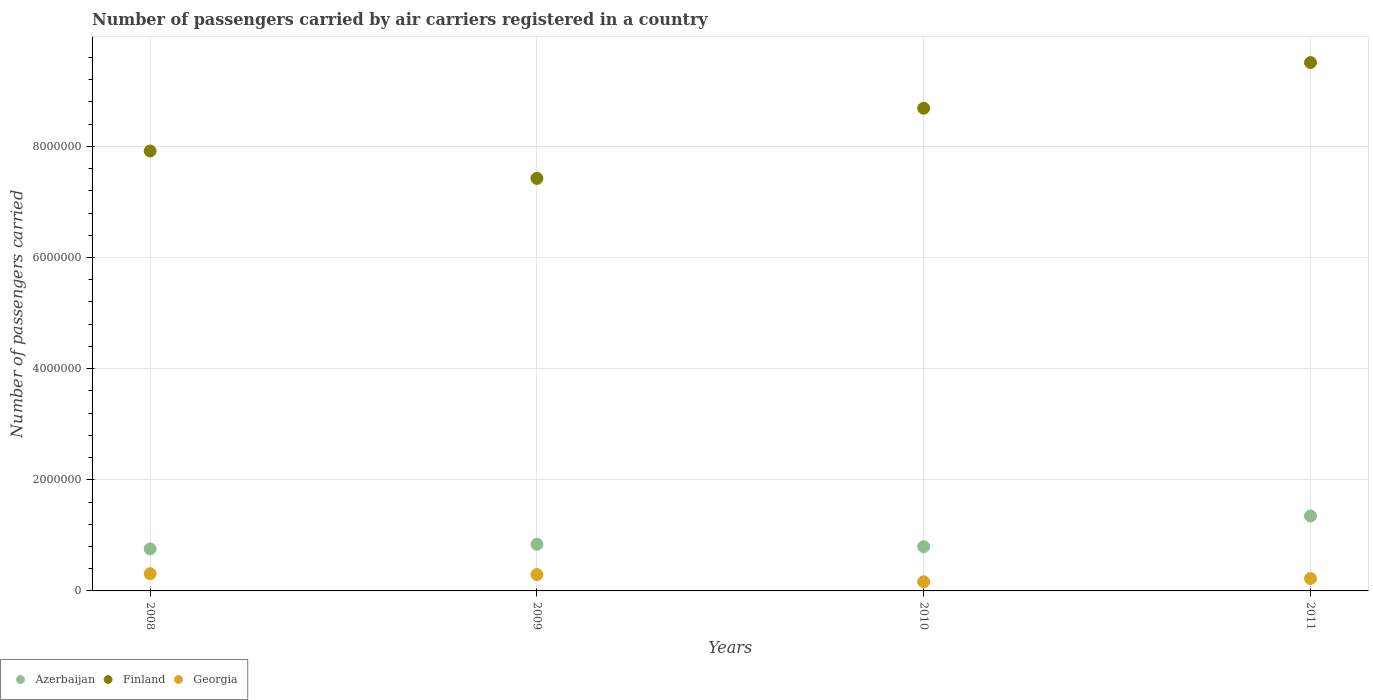How many different coloured dotlines are there?
Your answer should be very brief. 3. Is the number of dotlines equal to the number of legend labels?
Provide a short and direct response. Yes. What is the number of passengers carried by air carriers in Georgia in 2011?
Provide a short and direct response. 2.23e+05. Across all years, what is the maximum number of passengers carried by air carriers in Georgia?
Provide a short and direct response. 3.10e+05. Across all years, what is the minimum number of passengers carried by air carriers in Azerbaijan?
Provide a succinct answer. 7.56e+05. What is the total number of passengers carried by air carriers in Finland in the graph?
Your answer should be very brief. 3.35e+07. What is the difference between the number of passengers carried by air carriers in Georgia in 2008 and that in 2010?
Ensure brevity in your answer.  1.46e+05. What is the difference between the number of passengers carried by air carriers in Finland in 2008 and the number of passengers carried by air carriers in Georgia in 2009?
Provide a short and direct response. 7.62e+06. What is the average number of passengers carried by air carriers in Georgia per year?
Offer a terse response. 2.48e+05. In the year 2009, what is the difference between the number of passengers carried by air carriers in Georgia and number of passengers carried by air carriers in Azerbaijan?
Offer a terse response. -5.45e+05. In how many years, is the number of passengers carried by air carriers in Georgia greater than 8400000?
Offer a very short reply. 0. What is the ratio of the number of passengers carried by air carriers in Georgia in 2010 to that in 2011?
Provide a short and direct response. 0.74. What is the difference between the highest and the second highest number of passengers carried by air carriers in Georgia?
Provide a short and direct response. 1.58e+04. What is the difference between the highest and the lowest number of passengers carried by air carriers in Georgia?
Give a very brief answer. 1.46e+05. In how many years, is the number of passengers carried by air carriers in Finland greater than the average number of passengers carried by air carriers in Finland taken over all years?
Offer a very short reply. 2. Is the sum of the number of passengers carried by air carriers in Azerbaijan in 2010 and 2011 greater than the maximum number of passengers carried by air carriers in Georgia across all years?
Ensure brevity in your answer.  Yes. Does the number of passengers carried by air carriers in Azerbaijan monotonically increase over the years?
Provide a succinct answer. No. Is the number of passengers carried by air carriers in Georgia strictly less than the number of passengers carried by air carriers in Finland over the years?
Offer a terse response. Yes. Does the graph contain any zero values?
Provide a succinct answer. No. Does the graph contain grids?
Ensure brevity in your answer.  Yes. How many legend labels are there?
Make the answer very short. 3. How are the legend labels stacked?
Make the answer very short. Horizontal. What is the title of the graph?
Offer a terse response. Number of passengers carried by air carriers registered in a country. Does "East Asia (developing only)" appear as one of the legend labels in the graph?
Make the answer very short. No. What is the label or title of the X-axis?
Offer a very short reply. Years. What is the label or title of the Y-axis?
Give a very brief answer. Number of passengers carried. What is the Number of passengers carried of Azerbaijan in 2008?
Give a very brief answer. 7.56e+05. What is the Number of passengers carried in Finland in 2008?
Ensure brevity in your answer.  7.92e+06. What is the Number of passengers carried of Georgia in 2008?
Your response must be concise. 3.10e+05. What is the Number of passengers carried of Azerbaijan in 2009?
Your answer should be very brief. 8.40e+05. What is the Number of passengers carried in Finland in 2009?
Your response must be concise. 7.42e+06. What is the Number of passengers carried in Georgia in 2009?
Your response must be concise. 2.94e+05. What is the Number of passengers carried of Azerbaijan in 2010?
Ensure brevity in your answer.  7.97e+05. What is the Number of passengers carried in Finland in 2010?
Your answer should be compact. 8.69e+06. What is the Number of passengers carried of Georgia in 2010?
Provide a short and direct response. 1.64e+05. What is the Number of passengers carried of Azerbaijan in 2011?
Your answer should be very brief. 1.35e+06. What is the Number of passengers carried in Finland in 2011?
Your answer should be very brief. 9.51e+06. What is the Number of passengers carried of Georgia in 2011?
Give a very brief answer. 2.23e+05. Across all years, what is the maximum Number of passengers carried in Azerbaijan?
Make the answer very short. 1.35e+06. Across all years, what is the maximum Number of passengers carried in Finland?
Offer a very short reply. 9.51e+06. Across all years, what is the maximum Number of passengers carried of Georgia?
Provide a succinct answer. 3.10e+05. Across all years, what is the minimum Number of passengers carried in Azerbaijan?
Make the answer very short. 7.56e+05. Across all years, what is the minimum Number of passengers carried of Finland?
Provide a succinct answer. 7.42e+06. Across all years, what is the minimum Number of passengers carried of Georgia?
Provide a succinct answer. 1.64e+05. What is the total Number of passengers carried of Azerbaijan in the graph?
Your answer should be compact. 3.74e+06. What is the total Number of passengers carried in Finland in the graph?
Keep it short and to the point. 3.35e+07. What is the total Number of passengers carried in Georgia in the graph?
Give a very brief answer. 9.92e+05. What is the difference between the Number of passengers carried of Azerbaijan in 2008 and that in 2009?
Provide a short and direct response. -8.32e+04. What is the difference between the Number of passengers carried in Finland in 2008 and that in 2009?
Ensure brevity in your answer.  4.93e+05. What is the difference between the Number of passengers carried of Georgia in 2008 and that in 2009?
Offer a very short reply. 1.58e+04. What is the difference between the Number of passengers carried of Azerbaijan in 2008 and that in 2010?
Offer a very short reply. -4.04e+04. What is the difference between the Number of passengers carried of Finland in 2008 and that in 2010?
Your answer should be very brief. -7.69e+05. What is the difference between the Number of passengers carried in Georgia in 2008 and that in 2010?
Ensure brevity in your answer.  1.46e+05. What is the difference between the Number of passengers carried in Azerbaijan in 2008 and that in 2011?
Offer a very short reply. -5.92e+05. What is the difference between the Number of passengers carried in Finland in 2008 and that in 2011?
Keep it short and to the point. -1.59e+06. What is the difference between the Number of passengers carried in Georgia in 2008 and that in 2011?
Offer a very short reply. 8.76e+04. What is the difference between the Number of passengers carried of Azerbaijan in 2009 and that in 2010?
Give a very brief answer. 4.28e+04. What is the difference between the Number of passengers carried in Finland in 2009 and that in 2010?
Offer a terse response. -1.26e+06. What is the difference between the Number of passengers carried in Georgia in 2009 and that in 2010?
Your answer should be very brief. 1.30e+05. What is the difference between the Number of passengers carried in Azerbaijan in 2009 and that in 2011?
Make the answer very short. -5.09e+05. What is the difference between the Number of passengers carried in Finland in 2009 and that in 2011?
Give a very brief answer. -2.08e+06. What is the difference between the Number of passengers carried of Georgia in 2009 and that in 2011?
Make the answer very short. 7.18e+04. What is the difference between the Number of passengers carried of Azerbaijan in 2010 and that in 2011?
Your answer should be very brief. -5.52e+05. What is the difference between the Number of passengers carried in Finland in 2010 and that in 2011?
Provide a short and direct response. -8.22e+05. What is the difference between the Number of passengers carried of Georgia in 2010 and that in 2011?
Give a very brief answer. -5.82e+04. What is the difference between the Number of passengers carried of Azerbaijan in 2008 and the Number of passengers carried of Finland in 2009?
Your answer should be compact. -6.67e+06. What is the difference between the Number of passengers carried in Azerbaijan in 2008 and the Number of passengers carried in Georgia in 2009?
Keep it short and to the point. 4.62e+05. What is the difference between the Number of passengers carried of Finland in 2008 and the Number of passengers carried of Georgia in 2009?
Provide a succinct answer. 7.62e+06. What is the difference between the Number of passengers carried in Azerbaijan in 2008 and the Number of passengers carried in Finland in 2010?
Your answer should be compact. -7.93e+06. What is the difference between the Number of passengers carried in Azerbaijan in 2008 and the Number of passengers carried in Georgia in 2010?
Ensure brevity in your answer.  5.92e+05. What is the difference between the Number of passengers carried in Finland in 2008 and the Number of passengers carried in Georgia in 2010?
Keep it short and to the point. 7.75e+06. What is the difference between the Number of passengers carried in Azerbaijan in 2008 and the Number of passengers carried in Finland in 2011?
Give a very brief answer. -8.75e+06. What is the difference between the Number of passengers carried of Azerbaijan in 2008 and the Number of passengers carried of Georgia in 2011?
Your answer should be compact. 5.34e+05. What is the difference between the Number of passengers carried of Finland in 2008 and the Number of passengers carried of Georgia in 2011?
Your response must be concise. 7.69e+06. What is the difference between the Number of passengers carried in Azerbaijan in 2009 and the Number of passengers carried in Finland in 2010?
Your response must be concise. -7.85e+06. What is the difference between the Number of passengers carried in Azerbaijan in 2009 and the Number of passengers carried in Georgia in 2010?
Keep it short and to the point. 6.75e+05. What is the difference between the Number of passengers carried in Finland in 2009 and the Number of passengers carried in Georgia in 2010?
Make the answer very short. 7.26e+06. What is the difference between the Number of passengers carried in Azerbaijan in 2009 and the Number of passengers carried in Finland in 2011?
Offer a terse response. -8.67e+06. What is the difference between the Number of passengers carried in Azerbaijan in 2009 and the Number of passengers carried in Georgia in 2011?
Make the answer very short. 6.17e+05. What is the difference between the Number of passengers carried in Finland in 2009 and the Number of passengers carried in Georgia in 2011?
Offer a very short reply. 7.20e+06. What is the difference between the Number of passengers carried in Azerbaijan in 2010 and the Number of passengers carried in Finland in 2011?
Provide a succinct answer. -8.71e+06. What is the difference between the Number of passengers carried in Azerbaijan in 2010 and the Number of passengers carried in Georgia in 2011?
Your response must be concise. 5.74e+05. What is the difference between the Number of passengers carried in Finland in 2010 and the Number of passengers carried in Georgia in 2011?
Offer a terse response. 8.46e+06. What is the average Number of passengers carried of Azerbaijan per year?
Ensure brevity in your answer.  9.35e+05. What is the average Number of passengers carried in Finland per year?
Keep it short and to the point. 8.38e+06. What is the average Number of passengers carried in Georgia per year?
Provide a short and direct response. 2.48e+05. In the year 2008, what is the difference between the Number of passengers carried in Azerbaijan and Number of passengers carried in Finland?
Your response must be concise. -7.16e+06. In the year 2008, what is the difference between the Number of passengers carried of Azerbaijan and Number of passengers carried of Georgia?
Make the answer very short. 4.46e+05. In the year 2008, what is the difference between the Number of passengers carried in Finland and Number of passengers carried in Georgia?
Give a very brief answer. 7.61e+06. In the year 2009, what is the difference between the Number of passengers carried in Azerbaijan and Number of passengers carried in Finland?
Keep it short and to the point. -6.58e+06. In the year 2009, what is the difference between the Number of passengers carried of Azerbaijan and Number of passengers carried of Georgia?
Offer a very short reply. 5.45e+05. In the year 2009, what is the difference between the Number of passengers carried in Finland and Number of passengers carried in Georgia?
Ensure brevity in your answer.  7.13e+06. In the year 2010, what is the difference between the Number of passengers carried in Azerbaijan and Number of passengers carried in Finland?
Make the answer very short. -7.89e+06. In the year 2010, what is the difference between the Number of passengers carried in Azerbaijan and Number of passengers carried in Georgia?
Offer a very short reply. 6.32e+05. In the year 2010, what is the difference between the Number of passengers carried of Finland and Number of passengers carried of Georgia?
Provide a short and direct response. 8.52e+06. In the year 2011, what is the difference between the Number of passengers carried in Azerbaijan and Number of passengers carried in Finland?
Your response must be concise. -8.16e+06. In the year 2011, what is the difference between the Number of passengers carried of Azerbaijan and Number of passengers carried of Georgia?
Offer a terse response. 1.13e+06. In the year 2011, what is the difference between the Number of passengers carried in Finland and Number of passengers carried in Georgia?
Ensure brevity in your answer.  9.29e+06. What is the ratio of the Number of passengers carried in Azerbaijan in 2008 to that in 2009?
Offer a very short reply. 0.9. What is the ratio of the Number of passengers carried in Finland in 2008 to that in 2009?
Provide a succinct answer. 1.07. What is the ratio of the Number of passengers carried of Georgia in 2008 to that in 2009?
Offer a very short reply. 1.05. What is the ratio of the Number of passengers carried of Azerbaijan in 2008 to that in 2010?
Provide a succinct answer. 0.95. What is the ratio of the Number of passengers carried of Finland in 2008 to that in 2010?
Make the answer very short. 0.91. What is the ratio of the Number of passengers carried of Georgia in 2008 to that in 2010?
Keep it short and to the point. 1.89. What is the ratio of the Number of passengers carried of Azerbaijan in 2008 to that in 2011?
Your answer should be very brief. 0.56. What is the ratio of the Number of passengers carried of Finland in 2008 to that in 2011?
Provide a short and direct response. 0.83. What is the ratio of the Number of passengers carried in Georgia in 2008 to that in 2011?
Make the answer very short. 1.39. What is the ratio of the Number of passengers carried of Azerbaijan in 2009 to that in 2010?
Offer a very short reply. 1.05. What is the ratio of the Number of passengers carried in Finland in 2009 to that in 2010?
Your response must be concise. 0.85. What is the ratio of the Number of passengers carried in Georgia in 2009 to that in 2010?
Offer a very short reply. 1.79. What is the ratio of the Number of passengers carried of Azerbaijan in 2009 to that in 2011?
Give a very brief answer. 0.62. What is the ratio of the Number of passengers carried in Finland in 2009 to that in 2011?
Your response must be concise. 0.78. What is the ratio of the Number of passengers carried of Georgia in 2009 to that in 2011?
Give a very brief answer. 1.32. What is the ratio of the Number of passengers carried of Azerbaijan in 2010 to that in 2011?
Ensure brevity in your answer.  0.59. What is the ratio of the Number of passengers carried in Finland in 2010 to that in 2011?
Make the answer very short. 0.91. What is the ratio of the Number of passengers carried of Georgia in 2010 to that in 2011?
Ensure brevity in your answer.  0.74. What is the difference between the highest and the second highest Number of passengers carried in Azerbaijan?
Your answer should be very brief. 5.09e+05. What is the difference between the highest and the second highest Number of passengers carried of Finland?
Ensure brevity in your answer.  8.22e+05. What is the difference between the highest and the second highest Number of passengers carried in Georgia?
Offer a terse response. 1.58e+04. What is the difference between the highest and the lowest Number of passengers carried in Azerbaijan?
Give a very brief answer. 5.92e+05. What is the difference between the highest and the lowest Number of passengers carried in Finland?
Offer a very short reply. 2.08e+06. What is the difference between the highest and the lowest Number of passengers carried in Georgia?
Ensure brevity in your answer.  1.46e+05. 